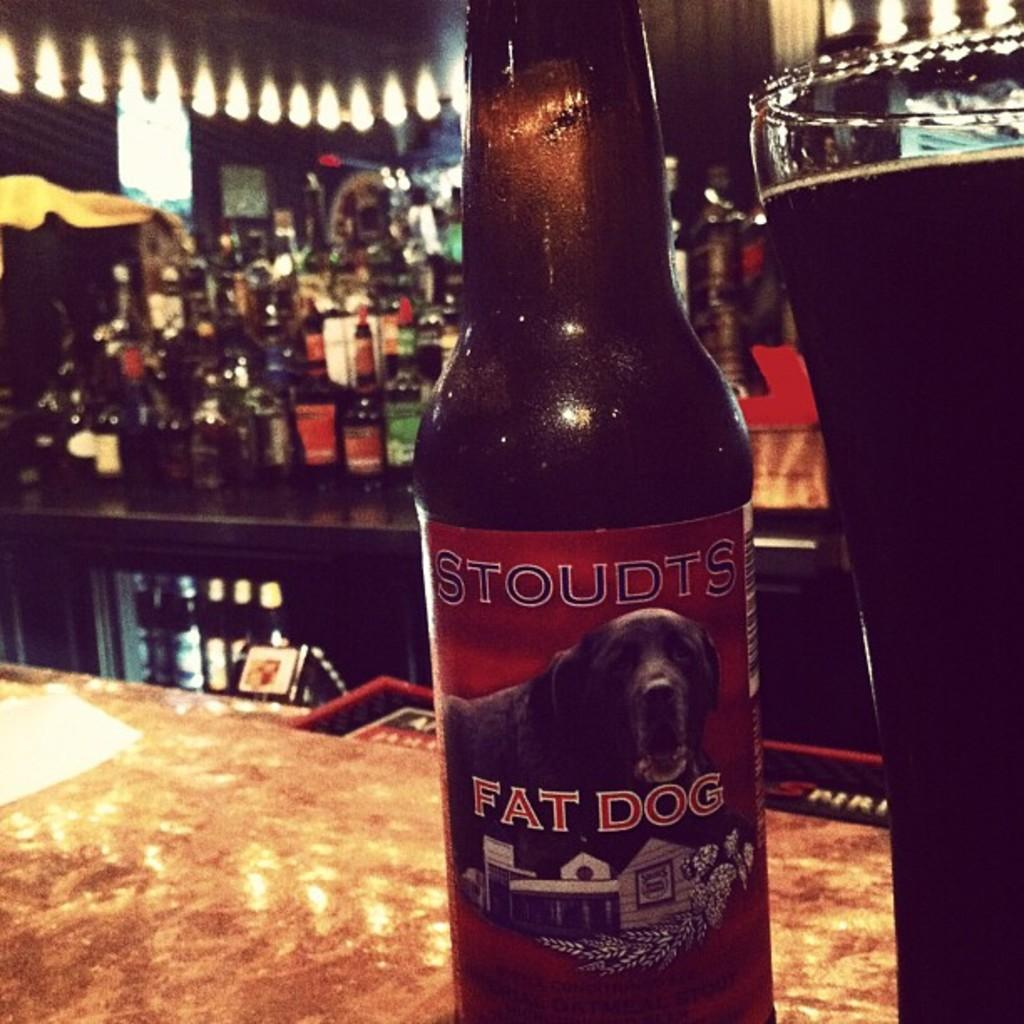What is the main object in the center of the image? There is a table in the center of the image. What can be found on the table? There is a glass and a wine bottle named "Fat dog" on the table. What can be seen in the background of the image? There is a light, another table, additional wine bottles, and a wall in the background of the image. What type of sponge is being used to clean the wine bottles in the image? There is no sponge present in the image, and no cleaning activity is taking place. Can you describe the picture hanging on the wall in the image? There is no picture hanging on the wall in the image; only a wine bottle named "Fat dog" and other wine bottles are visible on the table and in the background. 